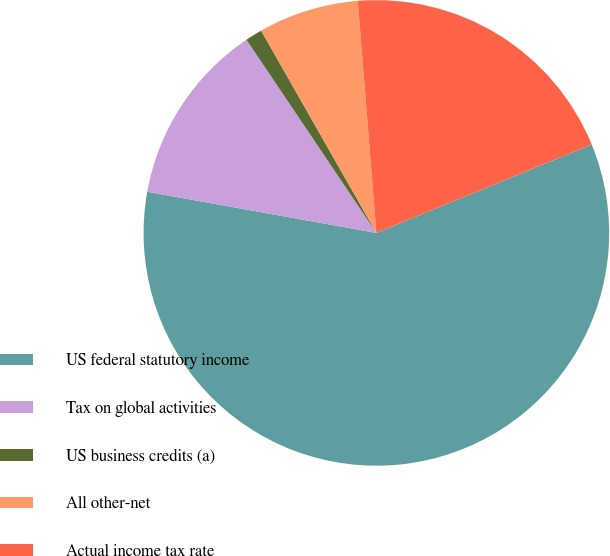<chart> <loc_0><loc_0><loc_500><loc_500><pie_chart><fcel>US federal statutory income<fcel>Tax on global activities<fcel>US business credits (a)<fcel>All other-net<fcel>Actual income tax rate<nl><fcel>59.03%<fcel>12.75%<fcel>1.18%<fcel>6.97%<fcel>20.07%<nl></chart> 